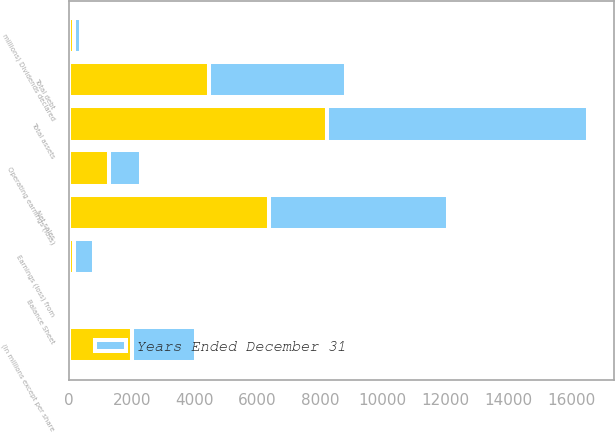Convert chart to OTSL. <chart><loc_0><loc_0><loc_500><loc_500><stacked_bar_chart><ecel><fcel>(In millions except per share<fcel>Net sales<fcel>Operating earnings (loss)<fcel>Earnings (loss) from<fcel>millions) Dividends declared<fcel>Balance Sheet<fcel>Total assets<fcel>Total debt<nl><fcel>nan<fcel>2017<fcel>6380<fcel>1282<fcel>155<fcel>162.9<fcel>1.93<fcel>8208<fcel>4471<nl><fcel>Years Ended December 31<fcel>2015<fcel>5695<fcel>994<fcel>640<fcel>201.8<fcel>1.43<fcel>8346<fcel>4349<nl></chart> 